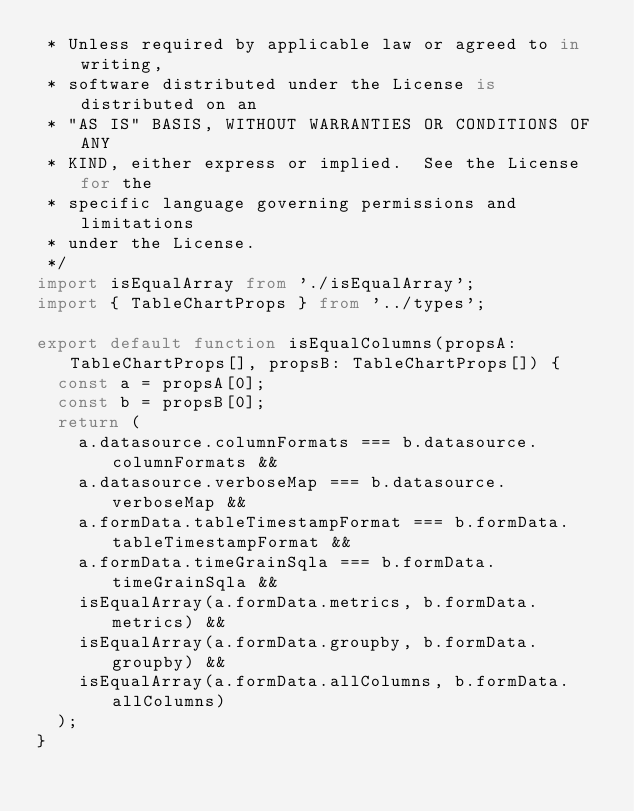Convert code to text. <code><loc_0><loc_0><loc_500><loc_500><_TypeScript_> * Unless required by applicable law or agreed to in writing,
 * software distributed under the License is distributed on an
 * "AS IS" BASIS, WITHOUT WARRANTIES OR CONDITIONS OF ANY
 * KIND, either express or implied.  See the License for the
 * specific language governing permissions and limitations
 * under the License.
 */
import isEqualArray from './isEqualArray';
import { TableChartProps } from '../types';

export default function isEqualColumns(propsA: TableChartProps[], propsB: TableChartProps[]) {
  const a = propsA[0];
  const b = propsB[0];
  return (
    a.datasource.columnFormats === b.datasource.columnFormats &&
    a.datasource.verboseMap === b.datasource.verboseMap &&
    a.formData.tableTimestampFormat === b.formData.tableTimestampFormat &&
    a.formData.timeGrainSqla === b.formData.timeGrainSqla &&
    isEqualArray(a.formData.metrics, b.formData.metrics) &&
    isEqualArray(a.formData.groupby, b.formData.groupby) &&
    isEqualArray(a.formData.allColumns, b.formData.allColumns)
  );
}
</code> 